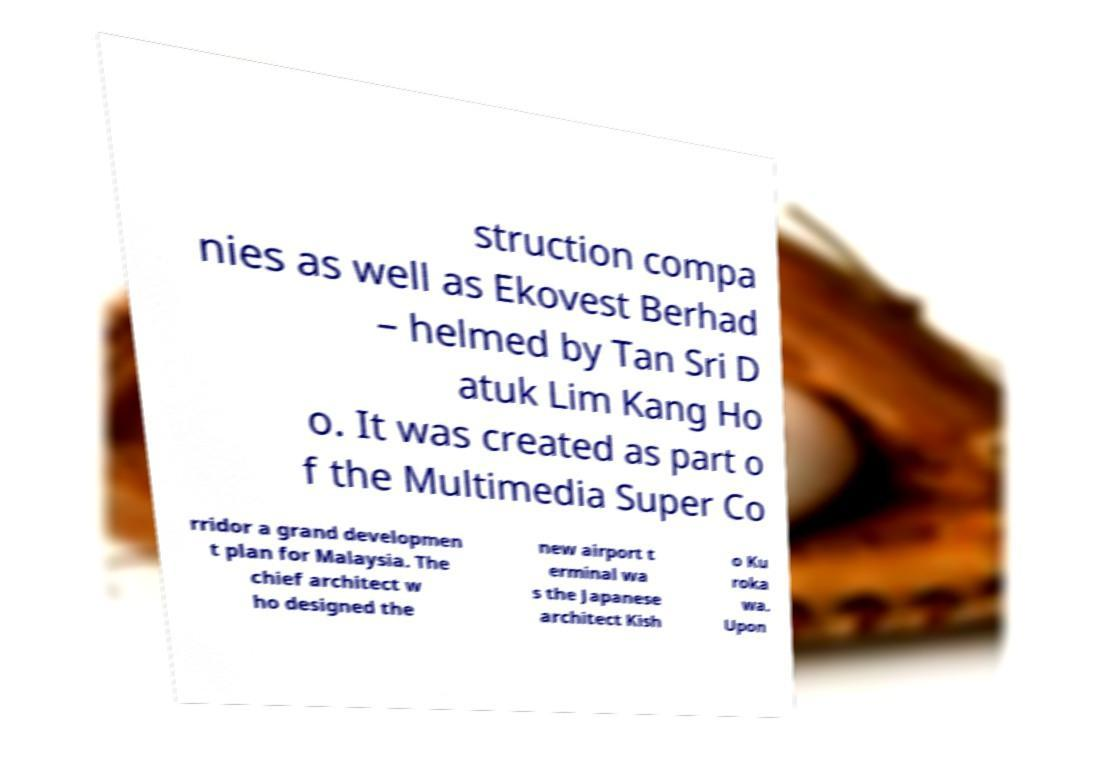There's text embedded in this image that I need extracted. Can you transcribe it verbatim? struction compa nies as well as Ekovest Berhad – helmed by Tan Sri D atuk Lim Kang Ho o. It was created as part o f the Multimedia Super Co rridor a grand developmen t plan for Malaysia. The chief architect w ho designed the new airport t erminal wa s the Japanese architect Kish o Ku roka wa. Upon 